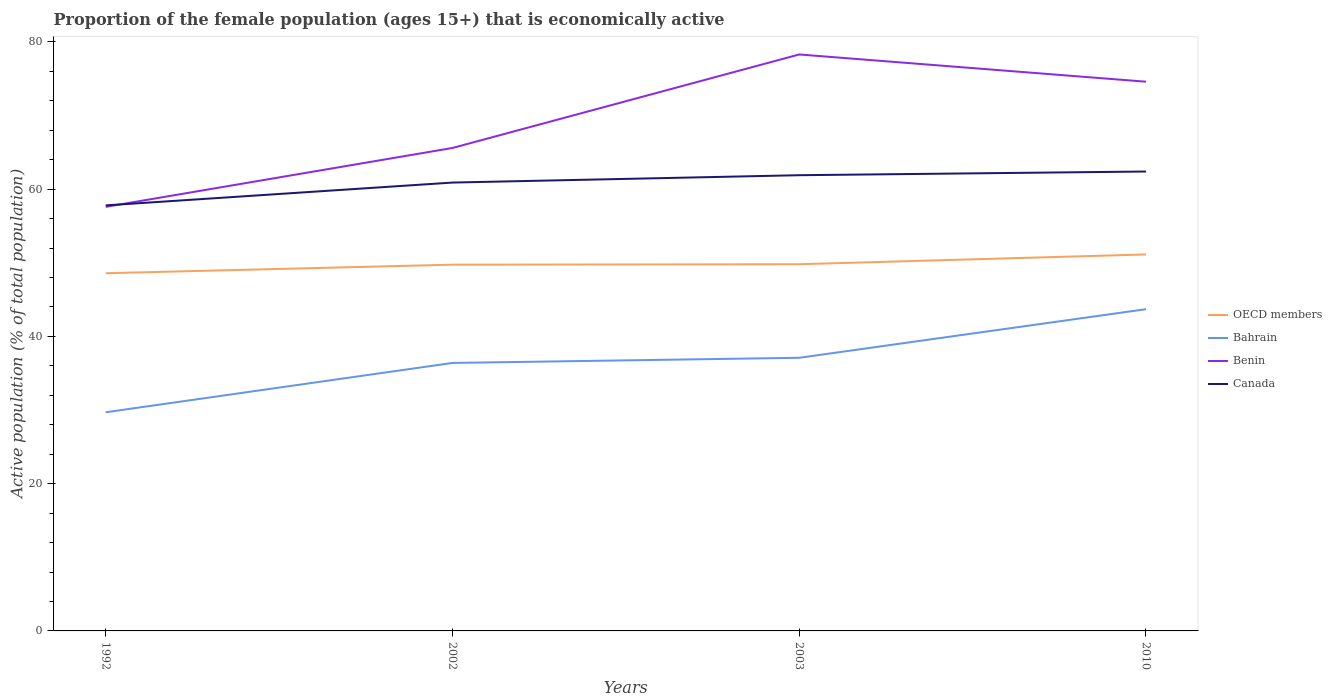Does the line corresponding to Bahrain intersect with the line corresponding to OECD members?
Your answer should be very brief. No. Is the number of lines equal to the number of legend labels?
Offer a very short reply. Yes. Across all years, what is the maximum proportion of the female population that is economically active in Bahrain?
Give a very brief answer. 29.7. In which year was the proportion of the female population that is economically active in Canada maximum?
Offer a terse response. 1992. What is the total proportion of the female population that is economically active in Bahrain in the graph?
Your answer should be very brief. -7.4. What is the difference between the highest and the second highest proportion of the female population that is economically active in Bahrain?
Provide a succinct answer. 14. How many lines are there?
Provide a succinct answer. 4. Does the graph contain any zero values?
Offer a very short reply. No. Does the graph contain grids?
Give a very brief answer. No. How many legend labels are there?
Make the answer very short. 4. What is the title of the graph?
Offer a very short reply. Proportion of the female population (ages 15+) that is economically active. Does "Ukraine" appear as one of the legend labels in the graph?
Your response must be concise. No. What is the label or title of the X-axis?
Give a very brief answer. Years. What is the label or title of the Y-axis?
Ensure brevity in your answer.  Active population (% of total population). What is the Active population (% of total population) of OECD members in 1992?
Make the answer very short. 48.59. What is the Active population (% of total population) of Bahrain in 1992?
Make the answer very short. 29.7. What is the Active population (% of total population) in Benin in 1992?
Your response must be concise. 57.6. What is the Active population (% of total population) of Canada in 1992?
Your answer should be very brief. 57.8. What is the Active population (% of total population) in OECD members in 2002?
Your answer should be compact. 49.75. What is the Active population (% of total population) of Bahrain in 2002?
Ensure brevity in your answer.  36.4. What is the Active population (% of total population) of Benin in 2002?
Keep it short and to the point. 65.6. What is the Active population (% of total population) in Canada in 2002?
Provide a succinct answer. 60.9. What is the Active population (% of total population) of OECD members in 2003?
Make the answer very short. 49.81. What is the Active population (% of total population) of Bahrain in 2003?
Provide a succinct answer. 37.1. What is the Active population (% of total population) in Benin in 2003?
Your response must be concise. 78.3. What is the Active population (% of total population) of Canada in 2003?
Provide a succinct answer. 61.9. What is the Active population (% of total population) of OECD members in 2010?
Keep it short and to the point. 51.14. What is the Active population (% of total population) in Bahrain in 2010?
Ensure brevity in your answer.  43.7. What is the Active population (% of total population) of Benin in 2010?
Ensure brevity in your answer.  74.6. What is the Active population (% of total population) in Canada in 2010?
Provide a succinct answer. 62.4. Across all years, what is the maximum Active population (% of total population) of OECD members?
Make the answer very short. 51.14. Across all years, what is the maximum Active population (% of total population) of Bahrain?
Your answer should be very brief. 43.7. Across all years, what is the maximum Active population (% of total population) in Benin?
Provide a short and direct response. 78.3. Across all years, what is the maximum Active population (% of total population) of Canada?
Give a very brief answer. 62.4. Across all years, what is the minimum Active population (% of total population) of OECD members?
Your answer should be compact. 48.59. Across all years, what is the minimum Active population (% of total population) of Bahrain?
Your response must be concise. 29.7. Across all years, what is the minimum Active population (% of total population) in Benin?
Provide a succinct answer. 57.6. Across all years, what is the minimum Active population (% of total population) of Canada?
Provide a short and direct response. 57.8. What is the total Active population (% of total population) of OECD members in the graph?
Keep it short and to the point. 199.28. What is the total Active population (% of total population) of Bahrain in the graph?
Give a very brief answer. 146.9. What is the total Active population (% of total population) in Benin in the graph?
Make the answer very short. 276.1. What is the total Active population (% of total population) in Canada in the graph?
Make the answer very short. 243. What is the difference between the Active population (% of total population) in OECD members in 1992 and that in 2002?
Offer a terse response. -1.16. What is the difference between the Active population (% of total population) in Bahrain in 1992 and that in 2002?
Ensure brevity in your answer.  -6.7. What is the difference between the Active population (% of total population) in Benin in 1992 and that in 2002?
Provide a succinct answer. -8. What is the difference between the Active population (% of total population) in OECD members in 1992 and that in 2003?
Provide a succinct answer. -1.22. What is the difference between the Active population (% of total population) of Bahrain in 1992 and that in 2003?
Keep it short and to the point. -7.4. What is the difference between the Active population (% of total population) of Benin in 1992 and that in 2003?
Provide a succinct answer. -20.7. What is the difference between the Active population (% of total population) in Canada in 1992 and that in 2003?
Offer a very short reply. -4.1. What is the difference between the Active population (% of total population) in OECD members in 1992 and that in 2010?
Make the answer very short. -2.55. What is the difference between the Active population (% of total population) of Benin in 1992 and that in 2010?
Offer a very short reply. -17. What is the difference between the Active population (% of total population) of Canada in 1992 and that in 2010?
Offer a terse response. -4.6. What is the difference between the Active population (% of total population) in OECD members in 2002 and that in 2003?
Offer a very short reply. -0.06. What is the difference between the Active population (% of total population) in Bahrain in 2002 and that in 2003?
Offer a very short reply. -0.7. What is the difference between the Active population (% of total population) of Benin in 2002 and that in 2003?
Provide a succinct answer. -12.7. What is the difference between the Active population (% of total population) of OECD members in 2002 and that in 2010?
Your answer should be very brief. -1.39. What is the difference between the Active population (% of total population) of Bahrain in 2002 and that in 2010?
Provide a short and direct response. -7.3. What is the difference between the Active population (% of total population) of Benin in 2002 and that in 2010?
Offer a terse response. -9. What is the difference between the Active population (% of total population) in OECD members in 2003 and that in 2010?
Your answer should be compact. -1.33. What is the difference between the Active population (% of total population) of Benin in 2003 and that in 2010?
Offer a terse response. 3.7. What is the difference between the Active population (% of total population) in Canada in 2003 and that in 2010?
Offer a terse response. -0.5. What is the difference between the Active population (% of total population) of OECD members in 1992 and the Active population (% of total population) of Bahrain in 2002?
Offer a very short reply. 12.19. What is the difference between the Active population (% of total population) of OECD members in 1992 and the Active population (% of total population) of Benin in 2002?
Offer a terse response. -17.01. What is the difference between the Active population (% of total population) in OECD members in 1992 and the Active population (% of total population) in Canada in 2002?
Your response must be concise. -12.31. What is the difference between the Active population (% of total population) in Bahrain in 1992 and the Active population (% of total population) in Benin in 2002?
Provide a succinct answer. -35.9. What is the difference between the Active population (% of total population) of Bahrain in 1992 and the Active population (% of total population) of Canada in 2002?
Offer a terse response. -31.2. What is the difference between the Active population (% of total population) of Benin in 1992 and the Active population (% of total population) of Canada in 2002?
Ensure brevity in your answer.  -3.3. What is the difference between the Active population (% of total population) of OECD members in 1992 and the Active population (% of total population) of Bahrain in 2003?
Your response must be concise. 11.49. What is the difference between the Active population (% of total population) of OECD members in 1992 and the Active population (% of total population) of Benin in 2003?
Make the answer very short. -29.71. What is the difference between the Active population (% of total population) in OECD members in 1992 and the Active population (% of total population) in Canada in 2003?
Your answer should be very brief. -13.31. What is the difference between the Active population (% of total population) in Bahrain in 1992 and the Active population (% of total population) in Benin in 2003?
Give a very brief answer. -48.6. What is the difference between the Active population (% of total population) of Bahrain in 1992 and the Active population (% of total population) of Canada in 2003?
Ensure brevity in your answer.  -32.2. What is the difference between the Active population (% of total population) of Benin in 1992 and the Active population (% of total population) of Canada in 2003?
Ensure brevity in your answer.  -4.3. What is the difference between the Active population (% of total population) of OECD members in 1992 and the Active population (% of total population) of Bahrain in 2010?
Provide a short and direct response. 4.89. What is the difference between the Active population (% of total population) in OECD members in 1992 and the Active population (% of total population) in Benin in 2010?
Offer a terse response. -26.01. What is the difference between the Active population (% of total population) in OECD members in 1992 and the Active population (% of total population) in Canada in 2010?
Give a very brief answer. -13.81. What is the difference between the Active population (% of total population) in Bahrain in 1992 and the Active population (% of total population) in Benin in 2010?
Provide a succinct answer. -44.9. What is the difference between the Active population (% of total population) in Bahrain in 1992 and the Active population (% of total population) in Canada in 2010?
Offer a very short reply. -32.7. What is the difference between the Active population (% of total population) of OECD members in 2002 and the Active population (% of total population) of Bahrain in 2003?
Your response must be concise. 12.65. What is the difference between the Active population (% of total population) in OECD members in 2002 and the Active population (% of total population) in Benin in 2003?
Provide a succinct answer. -28.55. What is the difference between the Active population (% of total population) in OECD members in 2002 and the Active population (% of total population) in Canada in 2003?
Your answer should be very brief. -12.15. What is the difference between the Active population (% of total population) of Bahrain in 2002 and the Active population (% of total population) of Benin in 2003?
Ensure brevity in your answer.  -41.9. What is the difference between the Active population (% of total population) in Bahrain in 2002 and the Active population (% of total population) in Canada in 2003?
Make the answer very short. -25.5. What is the difference between the Active population (% of total population) in OECD members in 2002 and the Active population (% of total population) in Bahrain in 2010?
Ensure brevity in your answer.  6.05. What is the difference between the Active population (% of total population) in OECD members in 2002 and the Active population (% of total population) in Benin in 2010?
Offer a terse response. -24.85. What is the difference between the Active population (% of total population) of OECD members in 2002 and the Active population (% of total population) of Canada in 2010?
Ensure brevity in your answer.  -12.65. What is the difference between the Active population (% of total population) of Bahrain in 2002 and the Active population (% of total population) of Benin in 2010?
Provide a succinct answer. -38.2. What is the difference between the Active population (% of total population) in Benin in 2002 and the Active population (% of total population) in Canada in 2010?
Offer a terse response. 3.2. What is the difference between the Active population (% of total population) of OECD members in 2003 and the Active population (% of total population) of Bahrain in 2010?
Your answer should be very brief. 6.11. What is the difference between the Active population (% of total population) of OECD members in 2003 and the Active population (% of total population) of Benin in 2010?
Ensure brevity in your answer.  -24.79. What is the difference between the Active population (% of total population) in OECD members in 2003 and the Active population (% of total population) in Canada in 2010?
Ensure brevity in your answer.  -12.59. What is the difference between the Active population (% of total population) in Bahrain in 2003 and the Active population (% of total population) in Benin in 2010?
Provide a short and direct response. -37.5. What is the difference between the Active population (% of total population) in Bahrain in 2003 and the Active population (% of total population) in Canada in 2010?
Provide a succinct answer. -25.3. What is the average Active population (% of total population) of OECD members per year?
Make the answer very short. 49.82. What is the average Active population (% of total population) in Bahrain per year?
Provide a succinct answer. 36.73. What is the average Active population (% of total population) of Benin per year?
Give a very brief answer. 69.03. What is the average Active population (% of total population) in Canada per year?
Give a very brief answer. 60.75. In the year 1992, what is the difference between the Active population (% of total population) of OECD members and Active population (% of total population) of Bahrain?
Make the answer very short. 18.89. In the year 1992, what is the difference between the Active population (% of total population) of OECD members and Active population (% of total population) of Benin?
Provide a succinct answer. -9.01. In the year 1992, what is the difference between the Active population (% of total population) of OECD members and Active population (% of total population) of Canada?
Your answer should be compact. -9.21. In the year 1992, what is the difference between the Active population (% of total population) of Bahrain and Active population (% of total population) of Benin?
Provide a succinct answer. -27.9. In the year 1992, what is the difference between the Active population (% of total population) in Bahrain and Active population (% of total population) in Canada?
Keep it short and to the point. -28.1. In the year 2002, what is the difference between the Active population (% of total population) of OECD members and Active population (% of total population) of Bahrain?
Offer a terse response. 13.35. In the year 2002, what is the difference between the Active population (% of total population) of OECD members and Active population (% of total population) of Benin?
Offer a very short reply. -15.85. In the year 2002, what is the difference between the Active population (% of total population) in OECD members and Active population (% of total population) in Canada?
Provide a short and direct response. -11.15. In the year 2002, what is the difference between the Active population (% of total population) in Bahrain and Active population (% of total population) in Benin?
Ensure brevity in your answer.  -29.2. In the year 2002, what is the difference between the Active population (% of total population) in Bahrain and Active population (% of total population) in Canada?
Offer a very short reply. -24.5. In the year 2003, what is the difference between the Active population (% of total population) in OECD members and Active population (% of total population) in Bahrain?
Make the answer very short. 12.71. In the year 2003, what is the difference between the Active population (% of total population) in OECD members and Active population (% of total population) in Benin?
Keep it short and to the point. -28.49. In the year 2003, what is the difference between the Active population (% of total population) in OECD members and Active population (% of total population) in Canada?
Your answer should be compact. -12.09. In the year 2003, what is the difference between the Active population (% of total population) in Bahrain and Active population (% of total population) in Benin?
Offer a terse response. -41.2. In the year 2003, what is the difference between the Active population (% of total population) of Bahrain and Active population (% of total population) of Canada?
Give a very brief answer. -24.8. In the year 2010, what is the difference between the Active population (% of total population) in OECD members and Active population (% of total population) in Bahrain?
Your answer should be compact. 7.44. In the year 2010, what is the difference between the Active population (% of total population) in OECD members and Active population (% of total population) in Benin?
Provide a short and direct response. -23.46. In the year 2010, what is the difference between the Active population (% of total population) in OECD members and Active population (% of total population) in Canada?
Your answer should be very brief. -11.26. In the year 2010, what is the difference between the Active population (% of total population) in Bahrain and Active population (% of total population) in Benin?
Offer a terse response. -30.9. In the year 2010, what is the difference between the Active population (% of total population) of Bahrain and Active population (% of total population) of Canada?
Provide a short and direct response. -18.7. What is the ratio of the Active population (% of total population) of OECD members in 1992 to that in 2002?
Keep it short and to the point. 0.98. What is the ratio of the Active population (% of total population) of Bahrain in 1992 to that in 2002?
Give a very brief answer. 0.82. What is the ratio of the Active population (% of total population) of Benin in 1992 to that in 2002?
Your answer should be very brief. 0.88. What is the ratio of the Active population (% of total population) of Canada in 1992 to that in 2002?
Offer a terse response. 0.95. What is the ratio of the Active population (% of total population) of OECD members in 1992 to that in 2003?
Offer a terse response. 0.98. What is the ratio of the Active population (% of total population) of Bahrain in 1992 to that in 2003?
Your answer should be very brief. 0.8. What is the ratio of the Active population (% of total population) of Benin in 1992 to that in 2003?
Ensure brevity in your answer.  0.74. What is the ratio of the Active population (% of total population) of Canada in 1992 to that in 2003?
Offer a terse response. 0.93. What is the ratio of the Active population (% of total population) in OECD members in 1992 to that in 2010?
Your answer should be compact. 0.95. What is the ratio of the Active population (% of total population) in Bahrain in 1992 to that in 2010?
Make the answer very short. 0.68. What is the ratio of the Active population (% of total population) in Benin in 1992 to that in 2010?
Make the answer very short. 0.77. What is the ratio of the Active population (% of total population) of Canada in 1992 to that in 2010?
Keep it short and to the point. 0.93. What is the ratio of the Active population (% of total population) in Bahrain in 2002 to that in 2003?
Provide a succinct answer. 0.98. What is the ratio of the Active population (% of total population) in Benin in 2002 to that in 2003?
Ensure brevity in your answer.  0.84. What is the ratio of the Active population (% of total population) in Canada in 2002 to that in 2003?
Provide a succinct answer. 0.98. What is the ratio of the Active population (% of total population) of OECD members in 2002 to that in 2010?
Make the answer very short. 0.97. What is the ratio of the Active population (% of total population) of Bahrain in 2002 to that in 2010?
Your response must be concise. 0.83. What is the ratio of the Active population (% of total population) in Benin in 2002 to that in 2010?
Make the answer very short. 0.88. What is the ratio of the Active population (% of total population) in Canada in 2002 to that in 2010?
Offer a very short reply. 0.98. What is the ratio of the Active population (% of total population) in Bahrain in 2003 to that in 2010?
Keep it short and to the point. 0.85. What is the ratio of the Active population (% of total population) in Benin in 2003 to that in 2010?
Give a very brief answer. 1.05. What is the difference between the highest and the second highest Active population (% of total population) in OECD members?
Your response must be concise. 1.33. What is the difference between the highest and the second highest Active population (% of total population) of Benin?
Your response must be concise. 3.7. What is the difference between the highest and the lowest Active population (% of total population) of OECD members?
Provide a short and direct response. 2.55. What is the difference between the highest and the lowest Active population (% of total population) in Bahrain?
Keep it short and to the point. 14. What is the difference between the highest and the lowest Active population (% of total population) in Benin?
Provide a succinct answer. 20.7. What is the difference between the highest and the lowest Active population (% of total population) of Canada?
Make the answer very short. 4.6. 